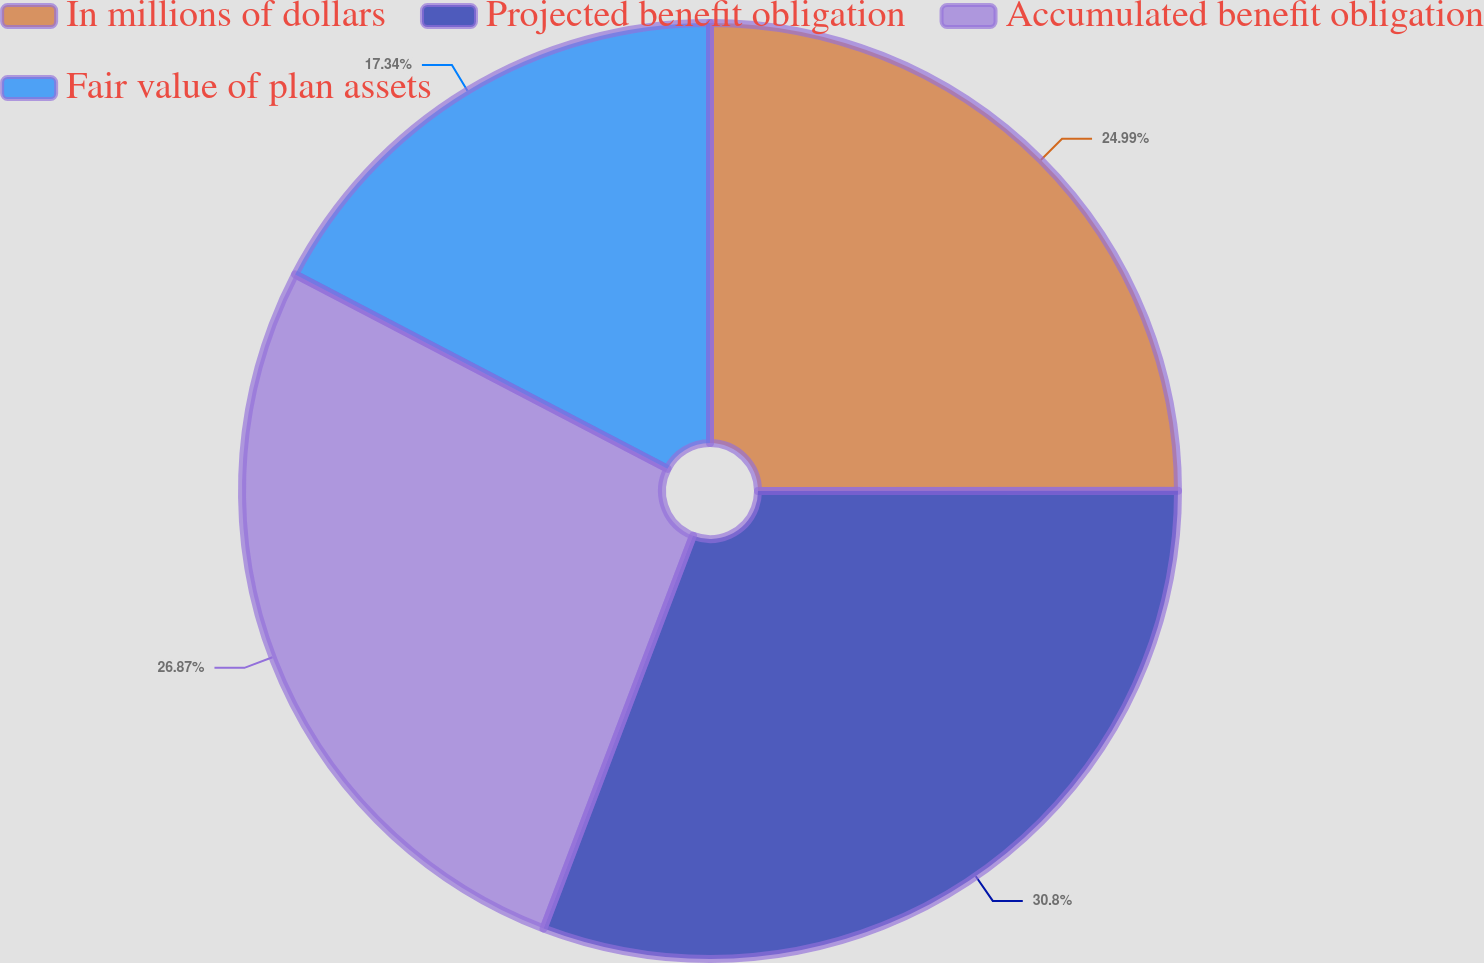<chart> <loc_0><loc_0><loc_500><loc_500><pie_chart><fcel>In millions of dollars<fcel>Projected benefit obligation<fcel>Accumulated benefit obligation<fcel>Fair value of plan assets<nl><fcel>24.99%<fcel>30.79%<fcel>26.87%<fcel>17.34%<nl></chart> 